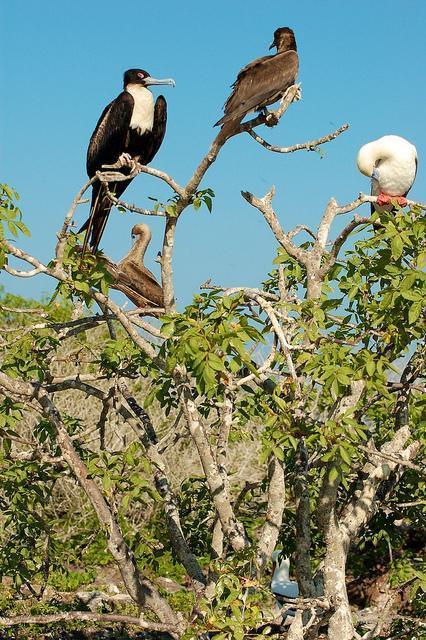How many birds are there?
Give a very brief answer. 4. 